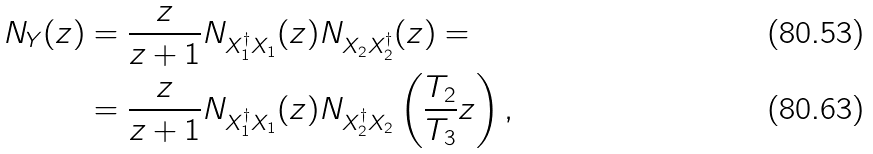Convert formula to latex. <formula><loc_0><loc_0><loc_500><loc_500>N _ { Y } ( z ) & = \frac { z } { z + 1 } N _ { X _ { 1 } ^ { \dagger } X _ { 1 } } ( z ) N _ { X _ { 2 } X _ { 2 } ^ { \dagger } } ( z ) = \\ & = \frac { z } { z + 1 } N _ { X _ { 1 } ^ { \dagger } X _ { 1 } } ( z ) N _ { X _ { 2 } ^ { \dagger } X _ { 2 } } \left ( \frac { T _ { 2 } } { T _ { 3 } } z \right ) ,</formula> 